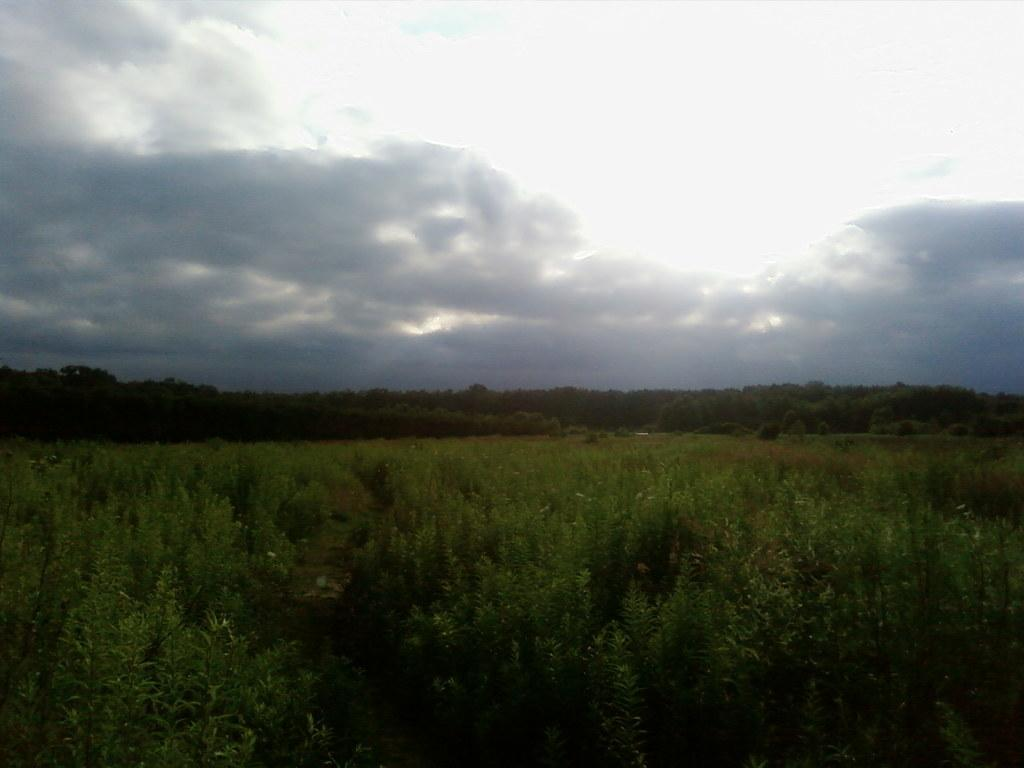What type of vegetation is present at the bottom of the image? There is greenery at the bottom of the image. What can be seen in the background of the image? There are trees and the sky visible in the background of the image. What type of land is visible in the image? The image does not show any specific type of land; it only features greenery, trees, and the sky. How many cabbages can be seen in the image? There are no cabbages present in the image. 